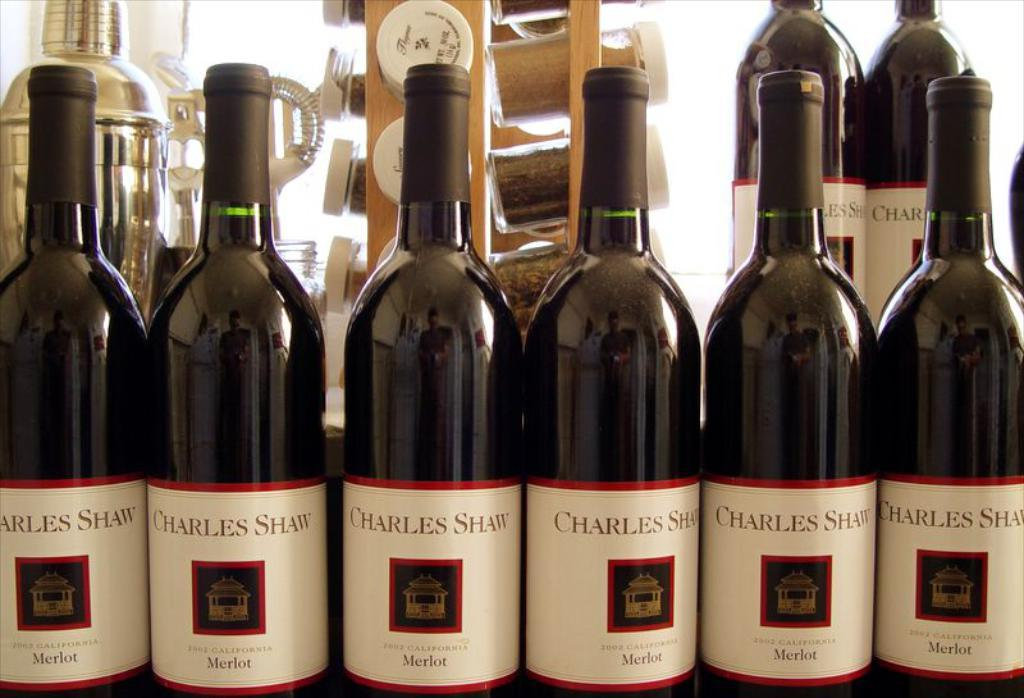<image>
Create a compact narrative representing the image presented. At least eight bottles of Charles Schwab wine are lined up. 